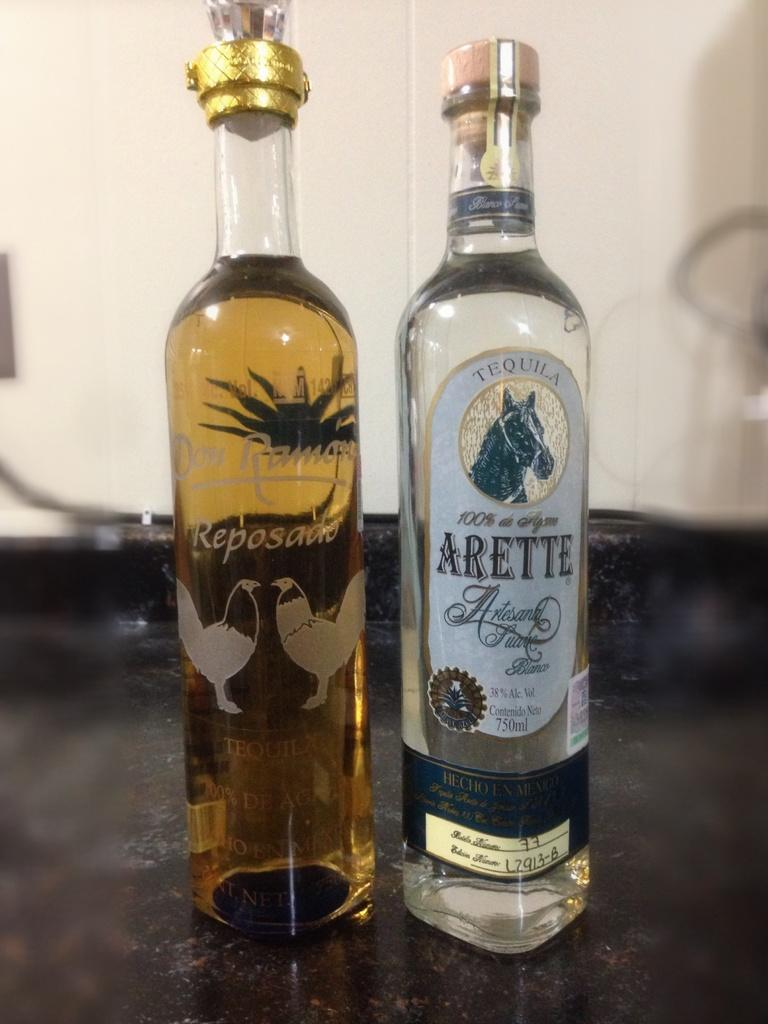<image>
Offer a succinct explanation of the picture presented. Two tall bottles are side by side, one filled with tequila and each with animals etched on the bottles. 